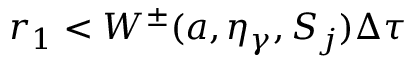Convert formula to latex. <formula><loc_0><loc_0><loc_500><loc_500>r _ { 1 } < W ^ { \pm } ( a , \eta _ { \gamma } , S _ { j } ) \Delta \tau</formula> 